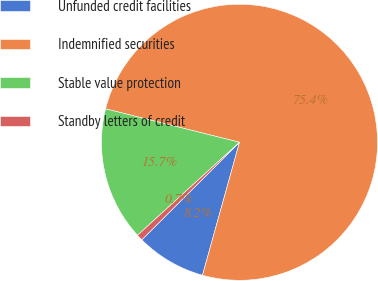<chart> <loc_0><loc_0><loc_500><loc_500><pie_chart><fcel>Unfunded credit facilities<fcel>Indemnified securities<fcel>Stable value protection<fcel>Standby letters of credit<nl><fcel>8.19%<fcel>75.42%<fcel>15.66%<fcel>0.72%<nl></chart> 